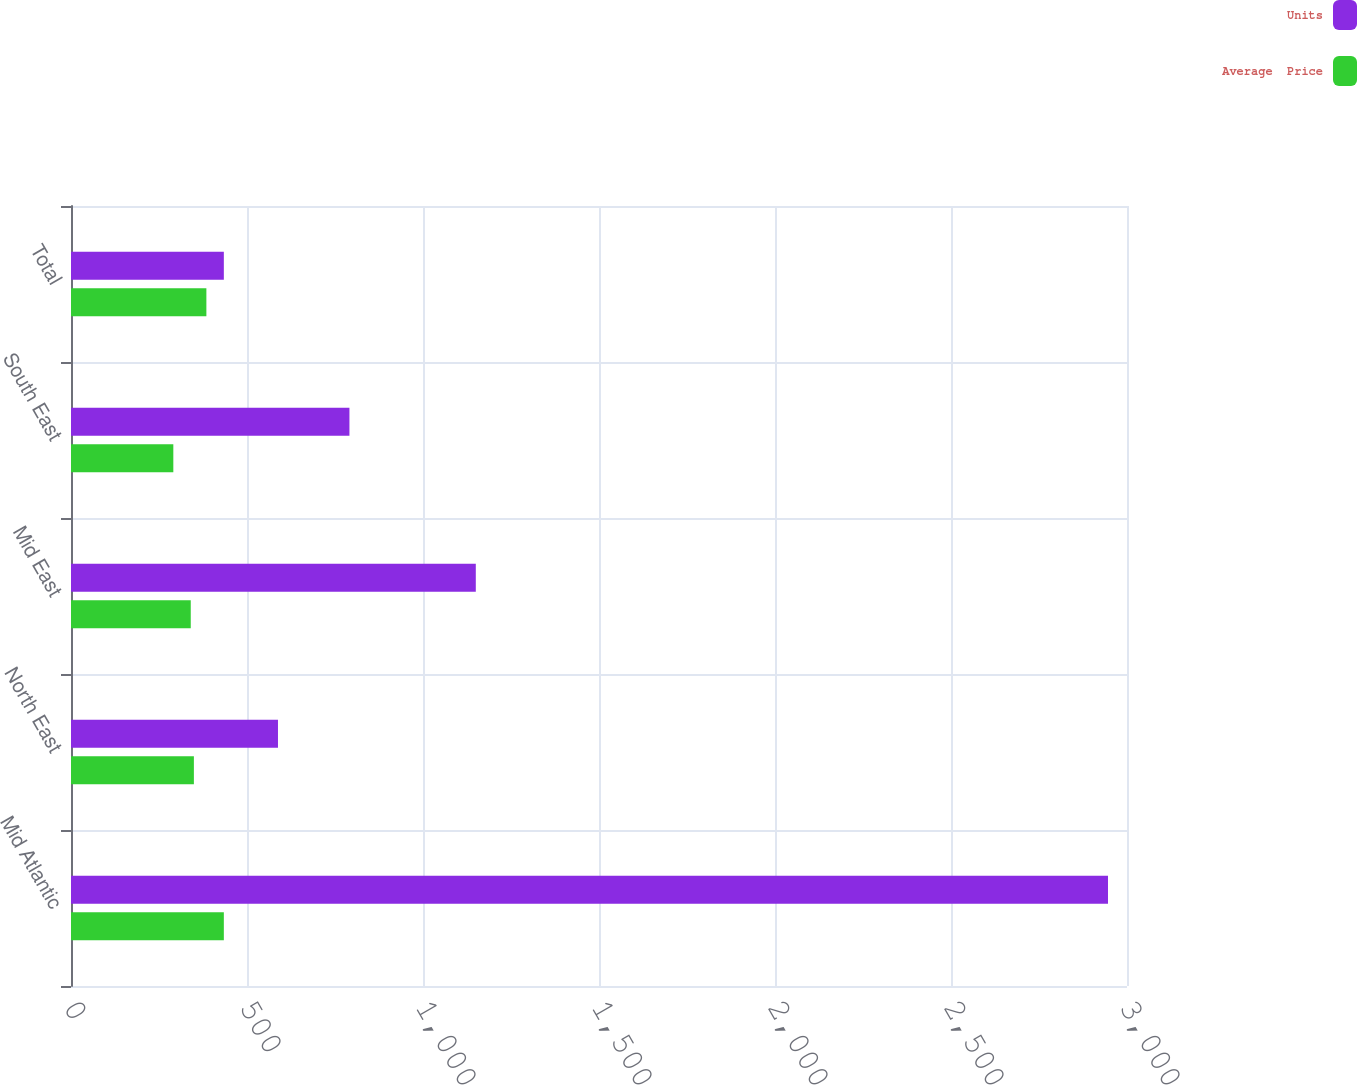Convert chart. <chart><loc_0><loc_0><loc_500><loc_500><stacked_bar_chart><ecel><fcel>Mid Atlantic<fcel>North East<fcel>Mid East<fcel>South East<fcel>Total<nl><fcel>Units<fcel>2946<fcel>588<fcel>1150<fcel>791<fcel>434.2<nl><fcel>Average  Price<fcel>434.2<fcel>349.1<fcel>340.2<fcel>290.7<fcel>384.6<nl></chart> 